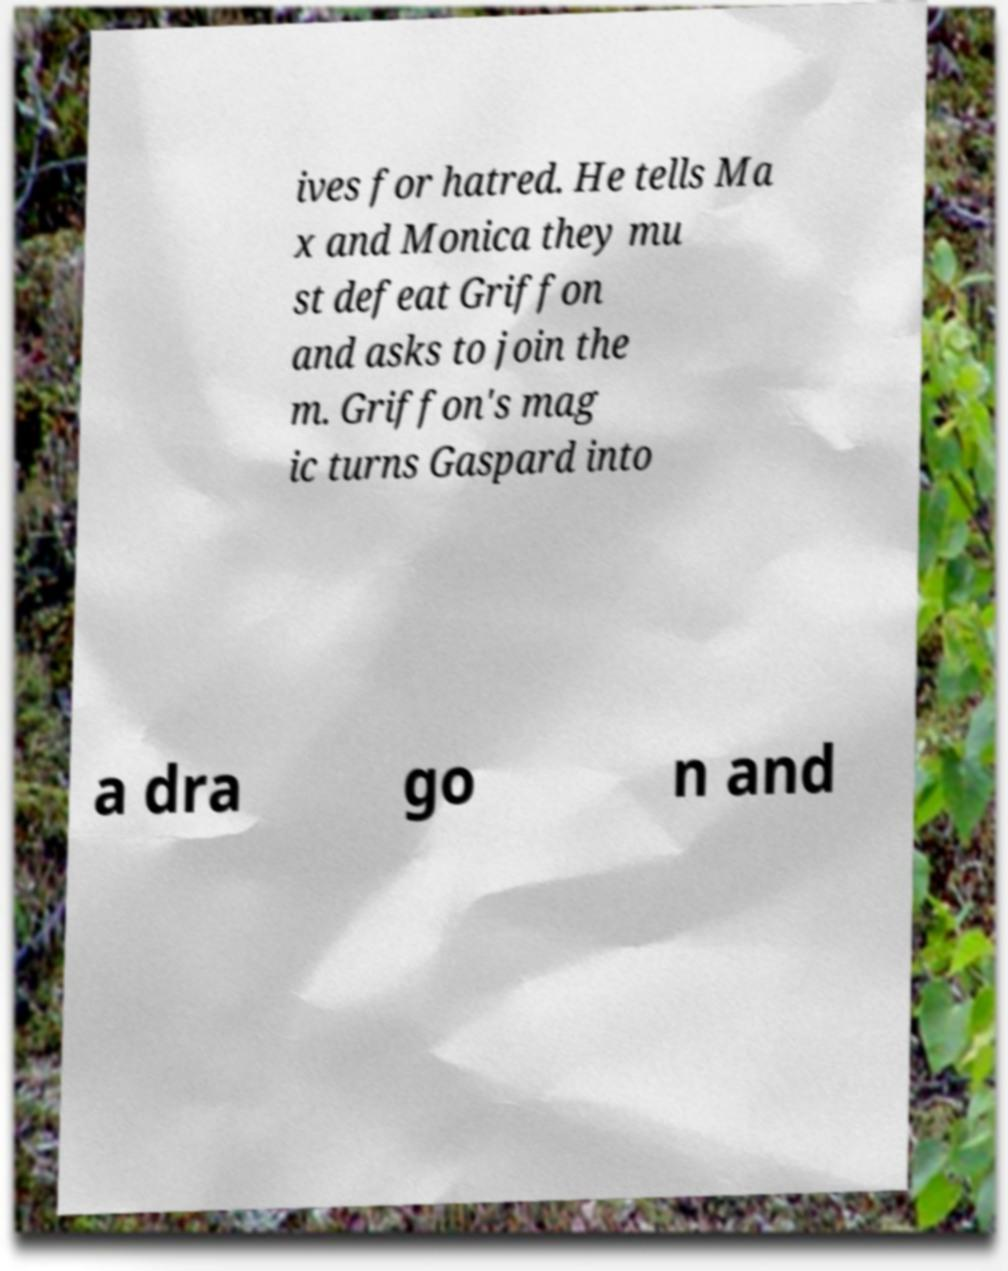Can you accurately transcribe the text from the provided image for me? ives for hatred. He tells Ma x and Monica they mu st defeat Griffon and asks to join the m. Griffon's mag ic turns Gaspard into a dra go n and 